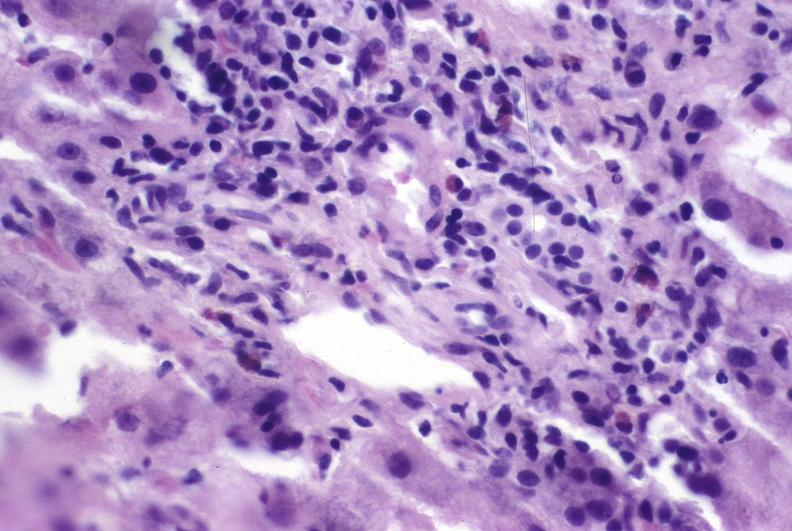does exact cause show autoimmune hepatitis?
Answer the question using a single word or phrase. No 